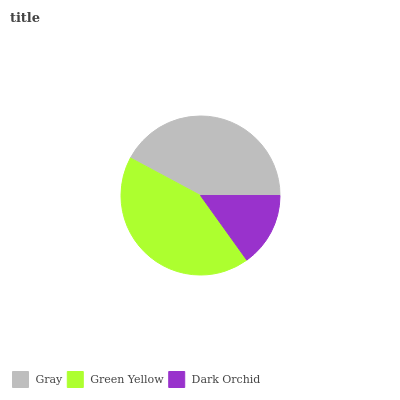Is Dark Orchid the minimum?
Answer yes or no. Yes. Is Green Yellow the maximum?
Answer yes or no. Yes. Is Green Yellow the minimum?
Answer yes or no. No. Is Dark Orchid the maximum?
Answer yes or no. No. Is Green Yellow greater than Dark Orchid?
Answer yes or no. Yes. Is Dark Orchid less than Green Yellow?
Answer yes or no. Yes. Is Dark Orchid greater than Green Yellow?
Answer yes or no. No. Is Green Yellow less than Dark Orchid?
Answer yes or no. No. Is Gray the high median?
Answer yes or no. Yes. Is Gray the low median?
Answer yes or no. Yes. Is Green Yellow the high median?
Answer yes or no. No. Is Green Yellow the low median?
Answer yes or no. No. 